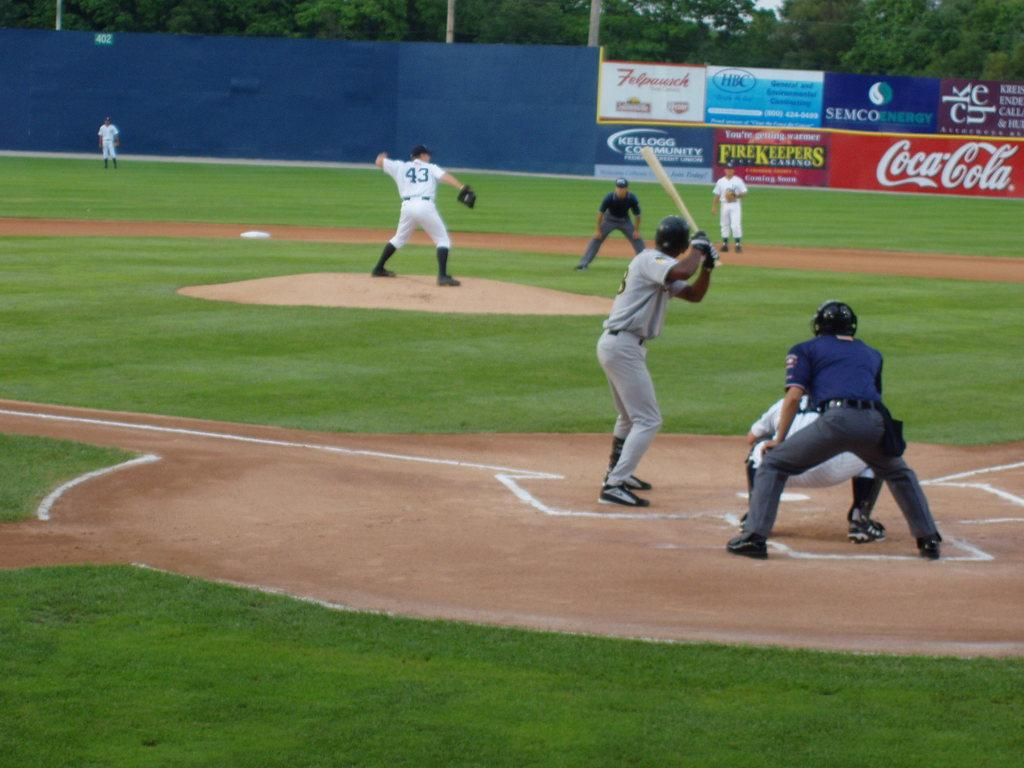<image>
Offer a succinct explanation of the picture presented. Coca Cola advertises at this minor league stadium. 